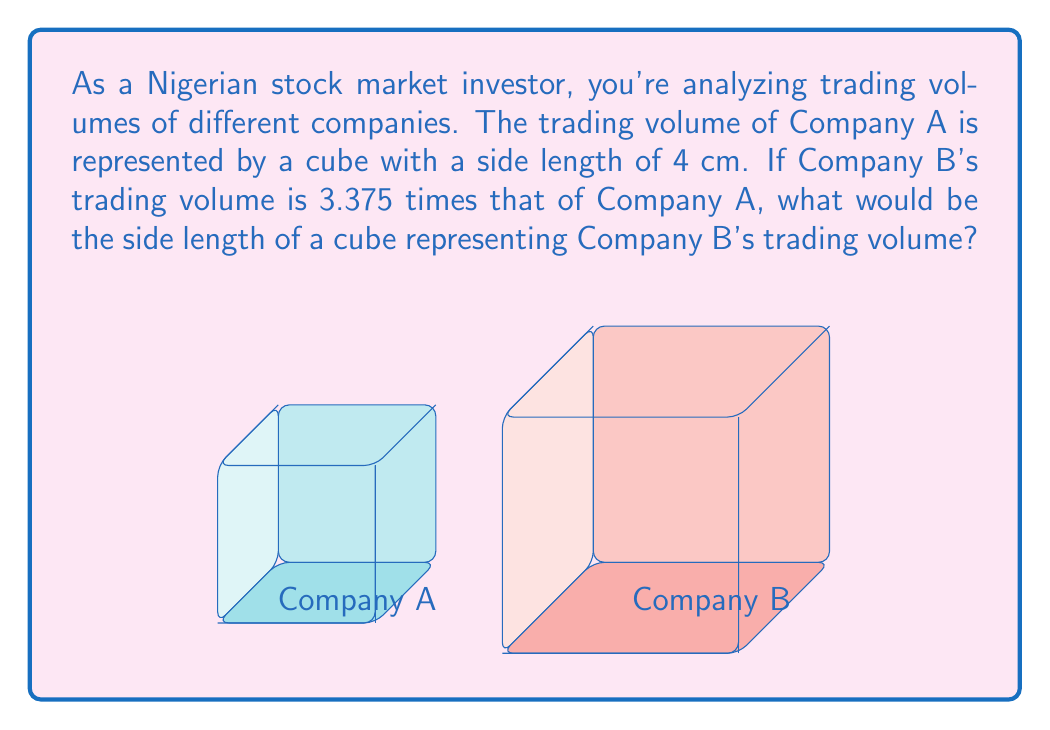Solve this math problem. Let's approach this step-by-step:

1) First, we need to understand the relationship between volume and side length of a cube. The volume of a cube is given by the formula:

   $$V = s^3$$

   where $V$ is the volume and $s$ is the side length.

2) We're told that Company A's trading volume is represented by a cube with side length 4 cm. So its volume is:

   $$V_A = 4^3 = 64 \text{ cm}^3$$

3) Company B's trading volume is 3.375 times that of Company A. So:

   $$V_B = 3.375 \times V_A = 3.375 \times 64 = 216 \text{ cm}^3$$

4) Now, we need to find the side length of a cube with this volume. We can use the cube root:

   $$s_B = \sqrt[3]{V_B} = \sqrt[3]{216}$$

5) Simplify:

   $$s_B = 6 \text{ cm}$$

Therefore, the side length of the cube representing Company B's trading volume would be 6 cm.
Answer: 6 cm 